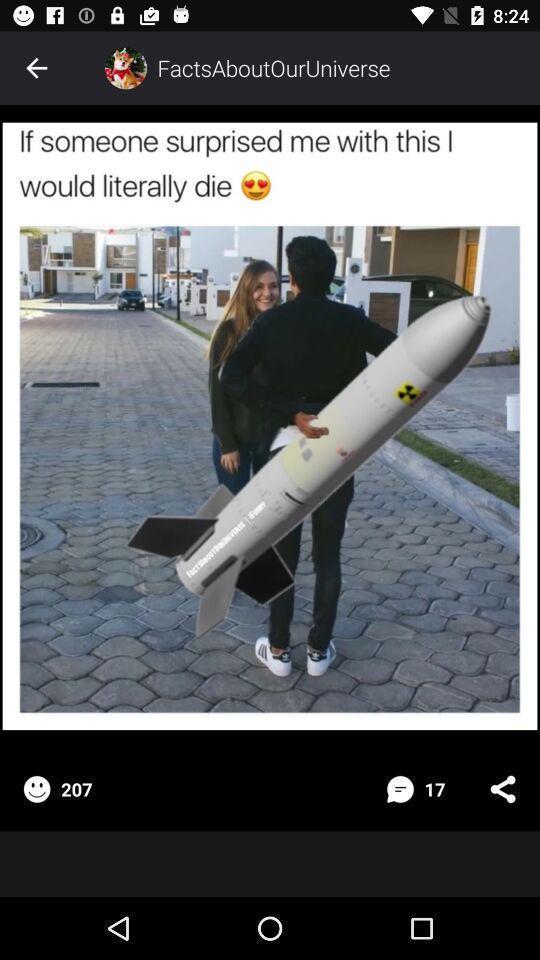Describe the visual elements of this screenshot. Screen shows an image in a social app. 